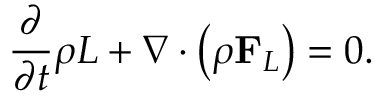<formula> <loc_0><loc_0><loc_500><loc_500>\frac { \partial } { \partial t } \rho L + \nabla \cdot \left ( { \rho { F } _ { L } } \right ) = 0 .</formula> 